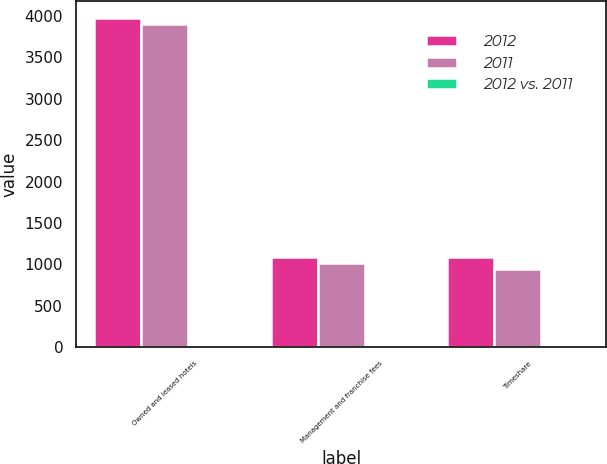Convert chart to OTSL. <chart><loc_0><loc_0><loc_500><loc_500><stacked_bar_chart><ecel><fcel>Owned and leased hotels<fcel>Management and franchise fees<fcel>Timeshare<nl><fcel>2012<fcel>3979<fcel>1088<fcel>1085<nl><fcel>2011<fcel>3898<fcel>1014<fcel>944<nl><fcel>2012 vs. 2011<fcel>2.1<fcel>7.3<fcel>14.9<nl></chart> 